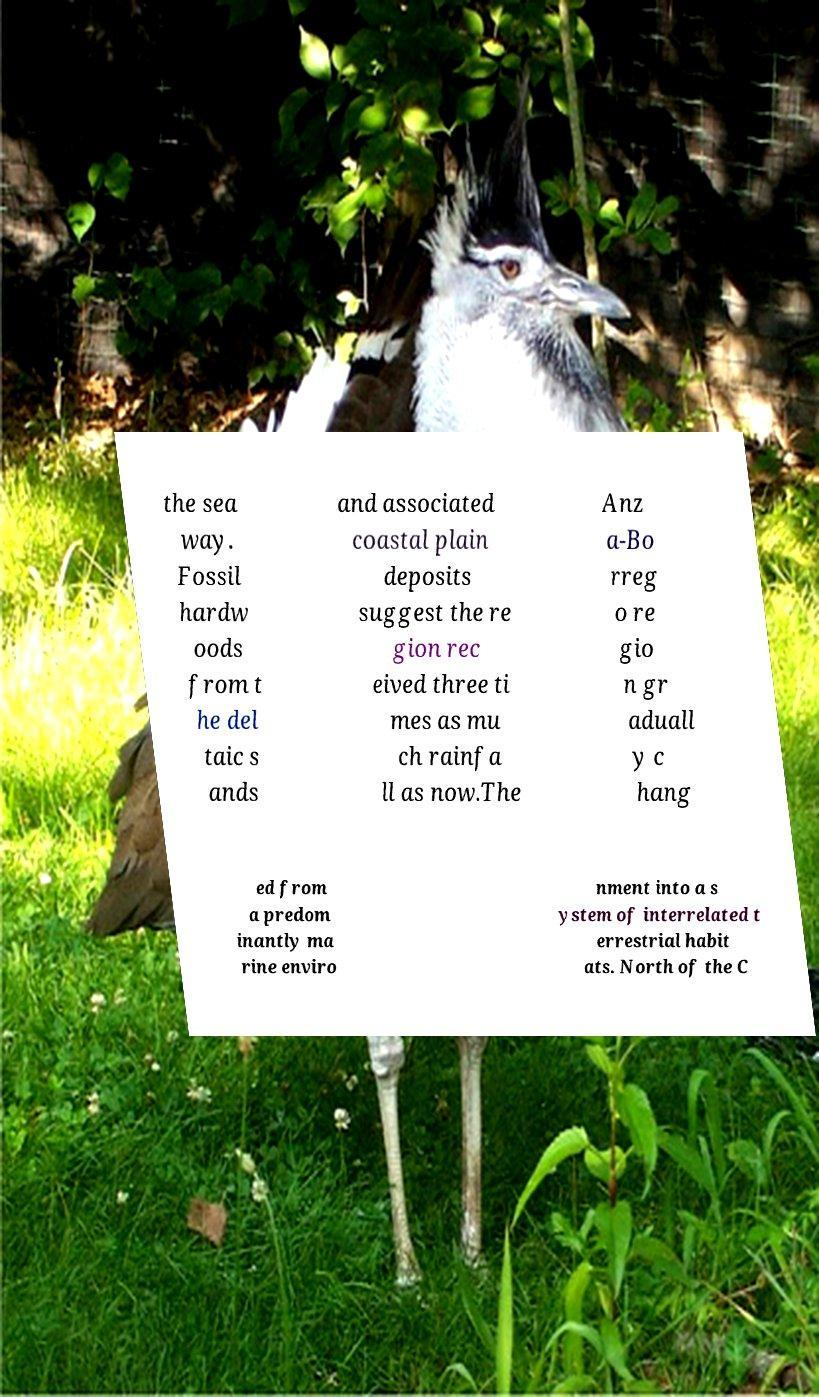What messages or text are displayed in this image? I need them in a readable, typed format. the sea way. Fossil hardw oods from t he del taic s ands and associated coastal plain deposits suggest the re gion rec eived three ti mes as mu ch rainfa ll as now.The Anz a-Bo rreg o re gio n gr aduall y c hang ed from a predom inantly ma rine enviro nment into a s ystem of interrelated t errestrial habit ats. North of the C 